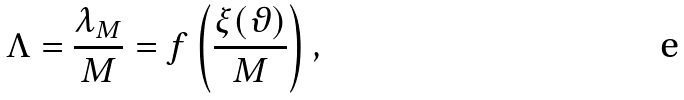<formula> <loc_0><loc_0><loc_500><loc_500>\Lambda = \frac { \lambda _ { M } } { M } = f \left ( \frac { \xi ( \vartheta ) } { M } \right ) ,</formula> 